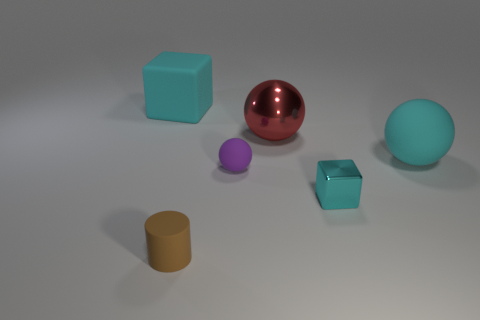What size is the ball that is the same color as the tiny cube?
Provide a short and direct response. Large. Is there anything else of the same color as the large block?
Provide a short and direct response. Yes. How many rubber cylinders are there?
Offer a very short reply. 1. What material is the cube that is to the right of the large cyan object that is behind the large red sphere made of?
Keep it short and to the point. Metal. There is a rubber thing to the right of the cube on the right side of the matte ball that is to the left of the cyan metal cube; what color is it?
Offer a very short reply. Cyan. Does the shiny block have the same color as the large block?
Your response must be concise. Yes. How many green spheres have the same size as the red metal ball?
Keep it short and to the point. 0. Are there more purple matte things behind the tiny cyan cube than tiny metallic things on the left side of the big red object?
Offer a terse response. Yes. There is a cube that is on the right side of the cyan rubber object left of the cyan rubber ball; what color is it?
Make the answer very short. Cyan. Is the brown object made of the same material as the big cube?
Offer a terse response. Yes. 